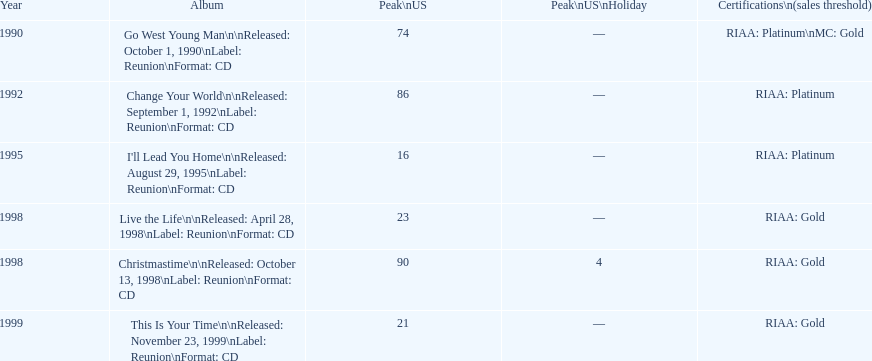How many entries can be found in the album? 6. 